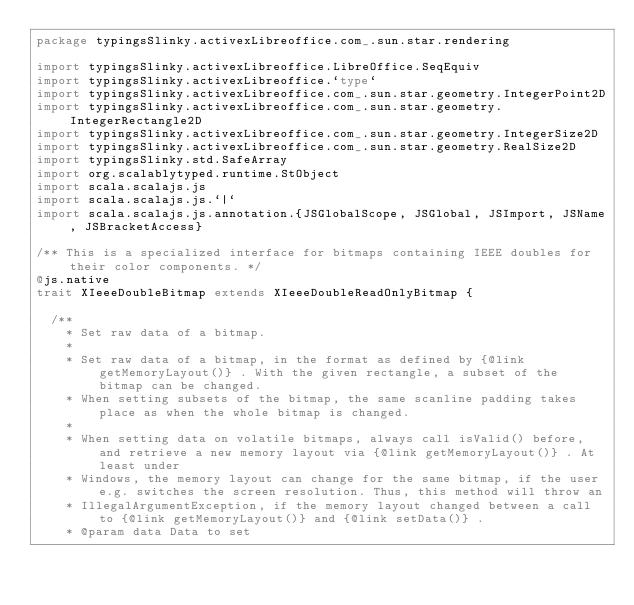Convert code to text. <code><loc_0><loc_0><loc_500><loc_500><_Scala_>package typingsSlinky.activexLibreoffice.com_.sun.star.rendering

import typingsSlinky.activexLibreoffice.LibreOffice.SeqEquiv
import typingsSlinky.activexLibreoffice.`type`
import typingsSlinky.activexLibreoffice.com_.sun.star.geometry.IntegerPoint2D
import typingsSlinky.activexLibreoffice.com_.sun.star.geometry.IntegerRectangle2D
import typingsSlinky.activexLibreoffice.com_.sun.star.geometry.IntegerSize2D
import typingsSlinky.activexLibreoffice.com_.sun.star.geometry.RealSize2D
import typingsSlinky.std.SafeArray
import org.scalablytyped.runtime.StObject
import scala.scalajs.js
import scala.scalajs.js.`|`
import scala.scalajs.js.annotation.{JSGlobalScope, JSGlobal, JSImport, JSName, JSBracketAccess}

/** This is a specialized interface for bitmaps containing IEEE doubles for their color components. */
@js.native
trait XIeeeDoubleBitmap extends XIeeeDoubleReadOnlyBitmap {
  
  /**
    * Set raw data of a bitmap.
    *
    * Set raw data of a bitmap, in the format as defined by {@link getMemoryLayout()} . With the given rectangle, a subset of the bitmap can be changed.
    * When setting subsets of the bitmap, the same scanline padding takes place as when the whole bitmap is changed.
    *
    * When setting data on volatile bitmaps, always call isValid() before, and retrieve a new memory layout via {@link getMemoryLayout()} . At least under
    * Windows, the memory layout can change for the same bitmap, if the user e.g. switches the screen resolution. Thus, this method will throw an
    * IllegalArgumentException, if the memory layout changed between a call to {@link getMemoryLayout()} and {@link setData()} .
    * @param data Data to set</code> 